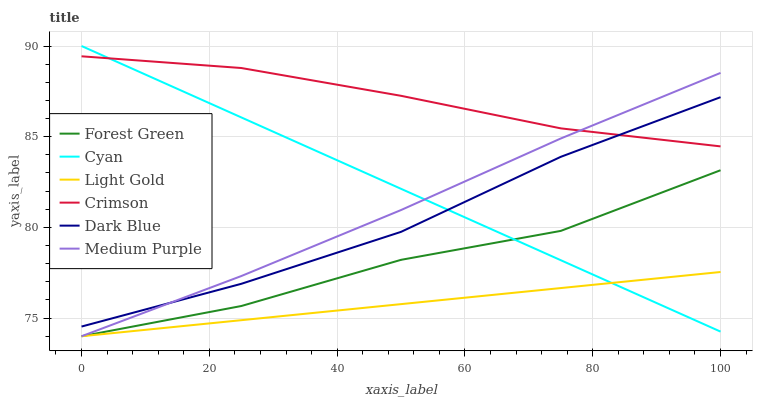Does Light Gold have the minimum area under the curve?
Answer yes or no. Yes. Does Crimson have the maximum area under the curve?
Answer yes or no. Yes. Does Dark Blue have the minimum area under the curve?
Answer yes or no. No. Does Dark Blue have the maximum area under the curve?
Answer yes or no. No. Is Light Gold the smoothest?
Answer yes or no. Yes. Is Forest Green the roughest?
Answer yes or no. Yes. Is Dark Blue the smoothest?
Answer yes or no. No. Is Dark Blue the roughest?
Answer yes or no. No. Does Dark Blue have the lowest value?
Answer yes or no. No. Does Cyan have the highest value?
Answer yes or no. Yes. Does Dark Blue have the highest value?
Answer yes or no. No. Is Light Gold less than Dark Blue?
Answer yes or no. Yes. Is Dark Blue greater than Forest Green?
Answer yes or no. Yes. Does Light Gold intersect Forest Green?
Answer yes or no. Yes. Is Light Gold less than Forest Green?
Answer yes or no. No. Is Light Gold greater than Forest Green?
Answer yes or no. No. Does Light Gold intersect Dark Blue?
Answer yes or no. No. 